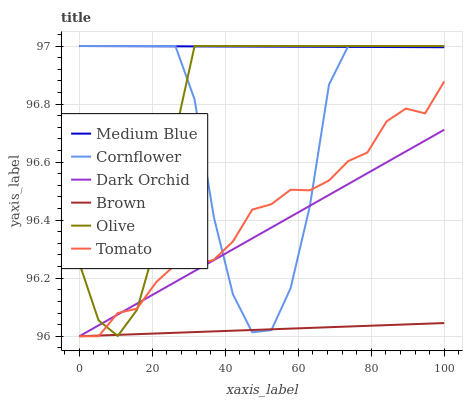Does Brown have the minimum area under the curve?
Answer yes or no. Yes. Does Medium Blue have the maximum area under the curve?
Answer yes or no. Yes. Does Cornflower have the minimum area under the curve?
Answer yes or no. No. Does Cornflower have the maximum area under the curve?
Answer yes or no. No. Is Dark Orchid the smoothest?
Answer yes or no. Yes. Is Cornflower the roughest?
Answer yes or no. Yes. Is Brown the smoothest?
Answer yes or no. No. Is Brown the roughest?
Answer yes or no. No. Does Cornflower have the lowest value?
Answer yes or no. No. Does Olive have the highest value?
Answer yes or no. Yes. Does Brown have the highest value?
Answer yes or no. No. Is Dark Orchid less than Medium Blue?
Answer yes or no. Yes. Is Medium Blue greater than Brown?
Answer yes or no. Yes. Does Dark Orchid intersect Tomato?
Answer yes or no. Yes. Is Dark Orchid less than Tomato?
Answer yes or no. No. Is Dark Orchid greater than Tomato?
Answer yes or no. No. Does Dark Orchid intersect Medium Blue?
Answer yes or no. No. 